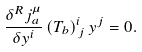<formula> <loc_0><loc_0><loc_500><loc_500>\frac { \delta ^ { R } j _ { a } ^ { \mu } } { \delta y ^ { i } } \left ( T _ { b } \right ) _ { \, j } ^ { i } y ^ { j } = 0 .</formula> 